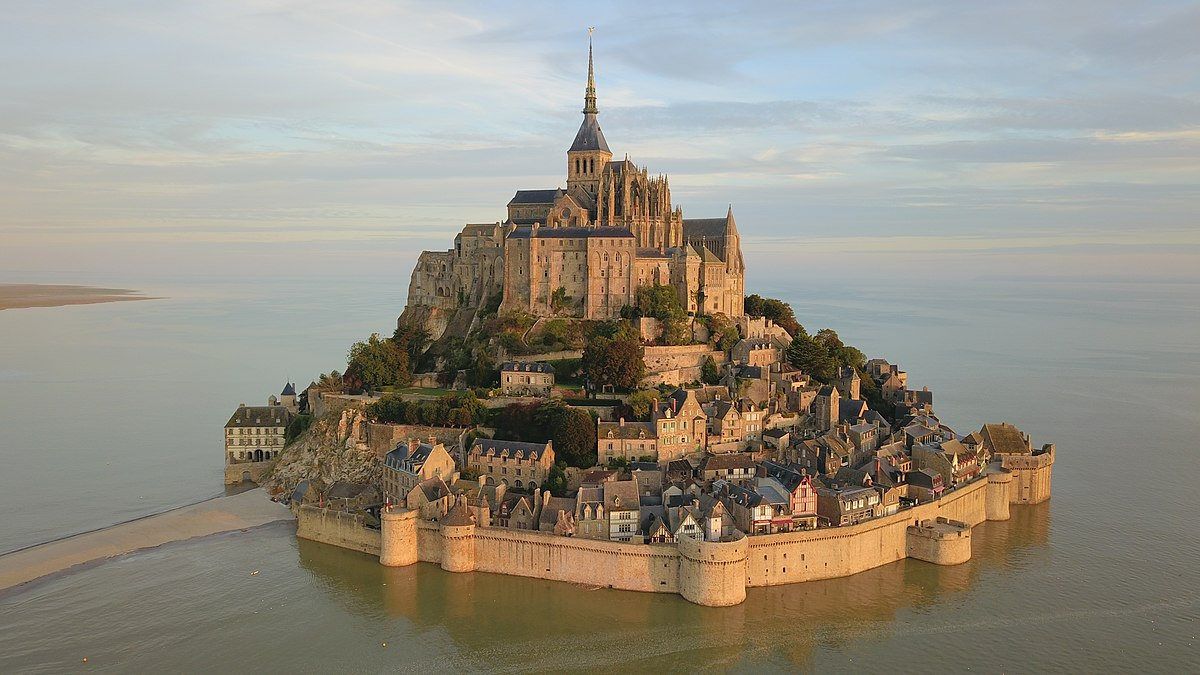What if this place suddenly detached from the mainland and floated away into the ocean? How would life change on Mont St Michel? If Mont St Michel were to suddenly detach from the mainland and float away into the ocean, it would transform into a drifting fortress adrift in the vastness of the sea. Life on Mont St Michel would shift dramatically as its inhabitants adjusted to a new, isolated existence. The abbey would become a beacon of maritime navigation, with its spire serving as a lighthouse guiding ships through uncharted waters. The village would adapt to a more self-sufficient lifestyle, relying on its fortifications for protection and its gardens for sustenance. The tides that once controlled access to the island would now dictate its journey across the ocean, leading to encounters with new cultures, marine wildlife, and probably even pirates. The community would grow closer, with monks, villagers, and scholars working together to maintain their floating sanctuary. Each day would bring new challenges and discoveries, transforming Mont St Michel into a symbol of human adaptability, resilience, and the spirit of adventure. 